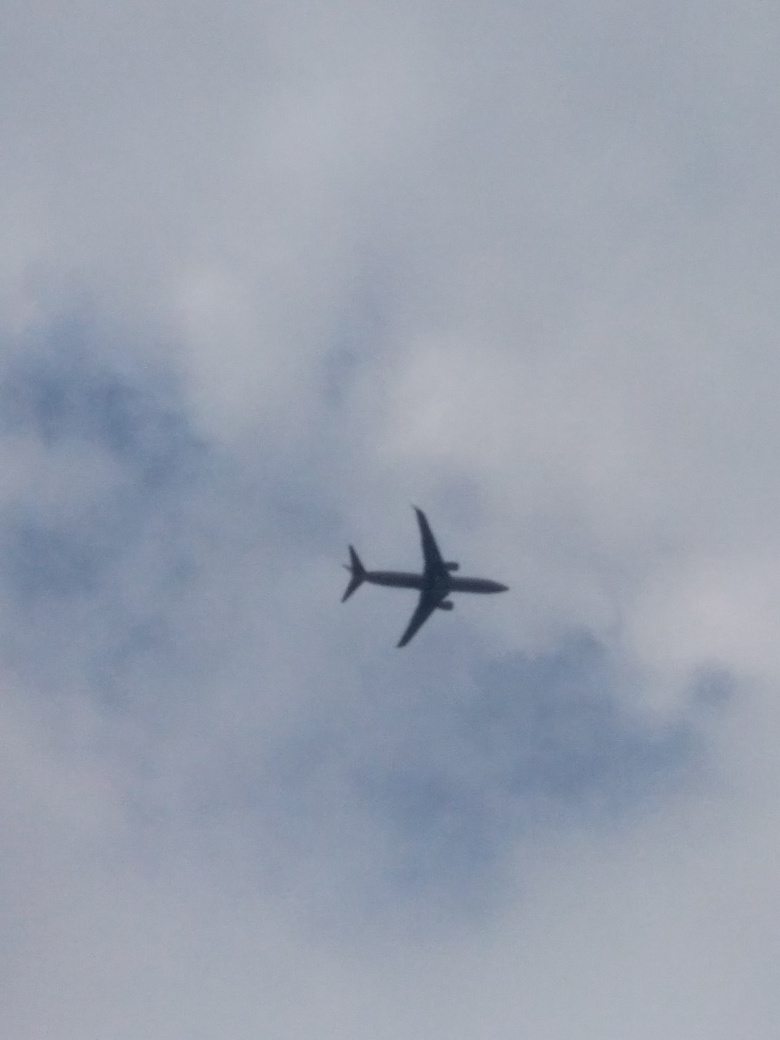What factors could cause the sky to appear overcast in this image? The sky could appear overcast due to the presence of dense cloud cover, which may indicate an approaching weather front or a local climate that is prone to such conditions. Additionally, environmental factors such as humidity and pollution can contribute to the appearance of an overcast sky. Does the presence of the airplane add anything to the understanding of the weather conditions in the image? The airplane that is visible against the cloudy sky can suggest that despite the overcast conditions, visibility is not severely compromised at the altitude the plane is flying. It also indicates that the weather is stable enough to allow for safe air travel at that moment. 